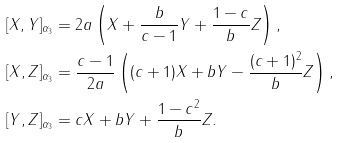<formula> <loc_0><loc_0><loc_500><loc_500>[ X , Y ] _ { \alpha _ { 3 } } & = 2 a \left ( X + \frac { b } { c - 1 } Y + \frac { 1 - c } { b } Z \right ) , \\ [ X , Z ] _ { \alpha _ { 3 } } & = \frac { c - 1 } { 2 a } \left ( ( c + 1 ) X + b Y - \frac { ( c + 1 ) ^ { 2 } } { b } Z \right ) , \\ [ Y , Z ] _ { \alpha _ { 3 } } & = c X + b Y + \frac { 1 - c ^ { 2 } } { b } Z .</formula> 